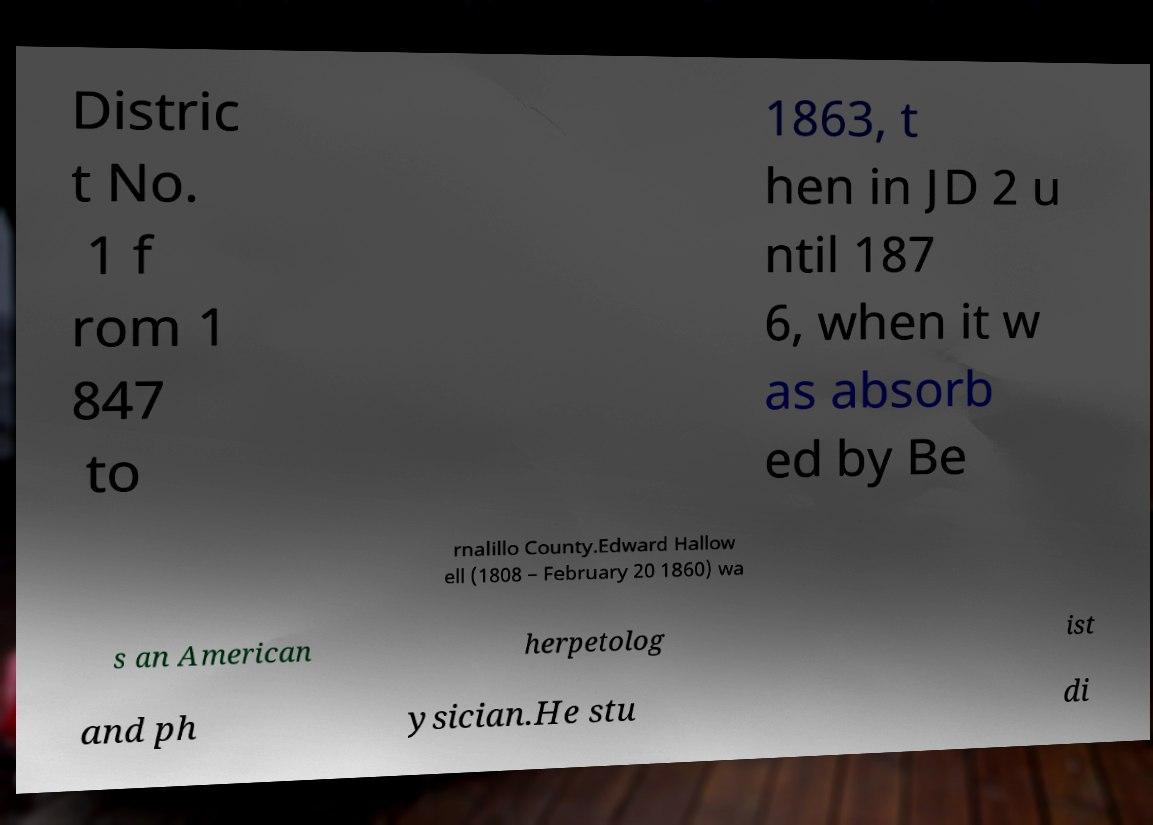There's text embedded in this image that I need extracted. Can you transcribe it verbatim? Distric t No. 1 f rom 1 847 to 1863, t hen in JD 2 u ntil 187 6, when it w as absorb ed by Be rnalillo County.Edward Hallow ell (1808 – February 20 1860) wa s an American herpetolog ist and ph ysician.He stu di 